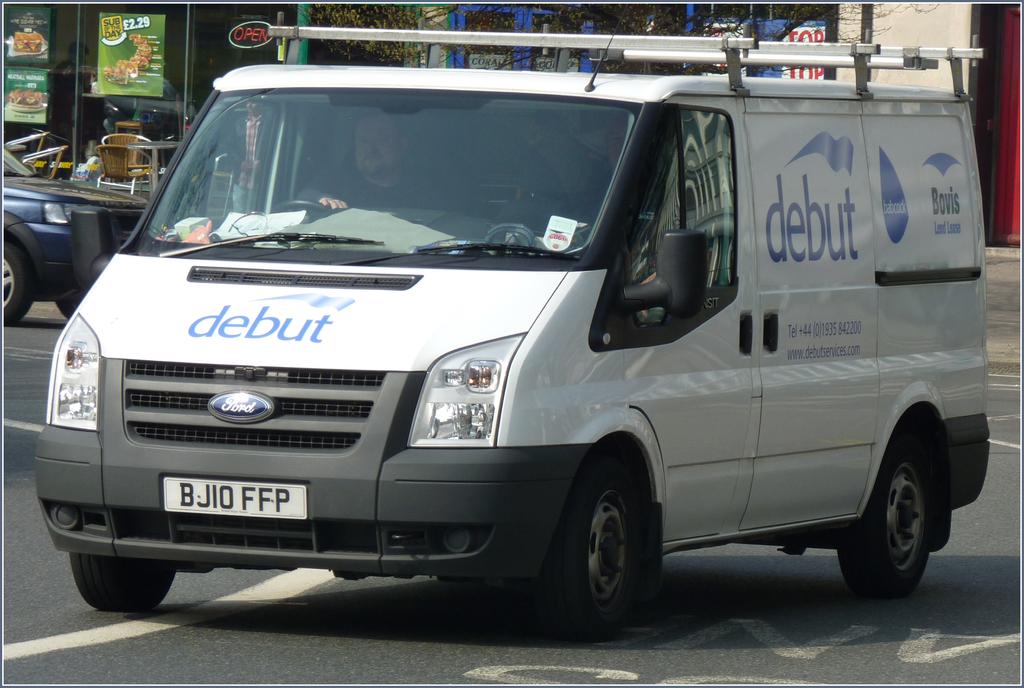What company does this van belong to?
Provide a short and direct response. Debut. 